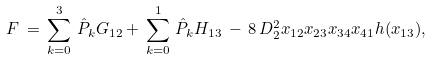<formula> <loc_0><loc_0><loc_500><loc_500>F \, = \, \sum ^ { 3 } _ { k = 0 } \, \hat { P } _ { k } G _ { 1 2 } + \, \sum ^ { 1 } _ { k = 0 } \, \hat { P } _ { k } H _ { 1 3 } \, - \, 8 \, D ^ { 2 } _ { 2 } x _ { 1 2 } x _ { 2 3 } x _ { 3 4 } x _ { 4 1 } h ( x _ { 1 3 } ) ,</formula> 